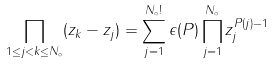<formula> <loc_0><loc_0><loc_500><loc_500>\prod _ { 1 \leq j < k \leq N _ { \circ } } ( z _ { k } - z _ { j } ) = \sum _ { j = 1 } ^ { N _ { \circ } ! } \epsilon ( P ) \prod _ { j = 1 } ^ { N _ { \circ } } z _ { j } ^ { P ( j ) - 1 }</formula> 